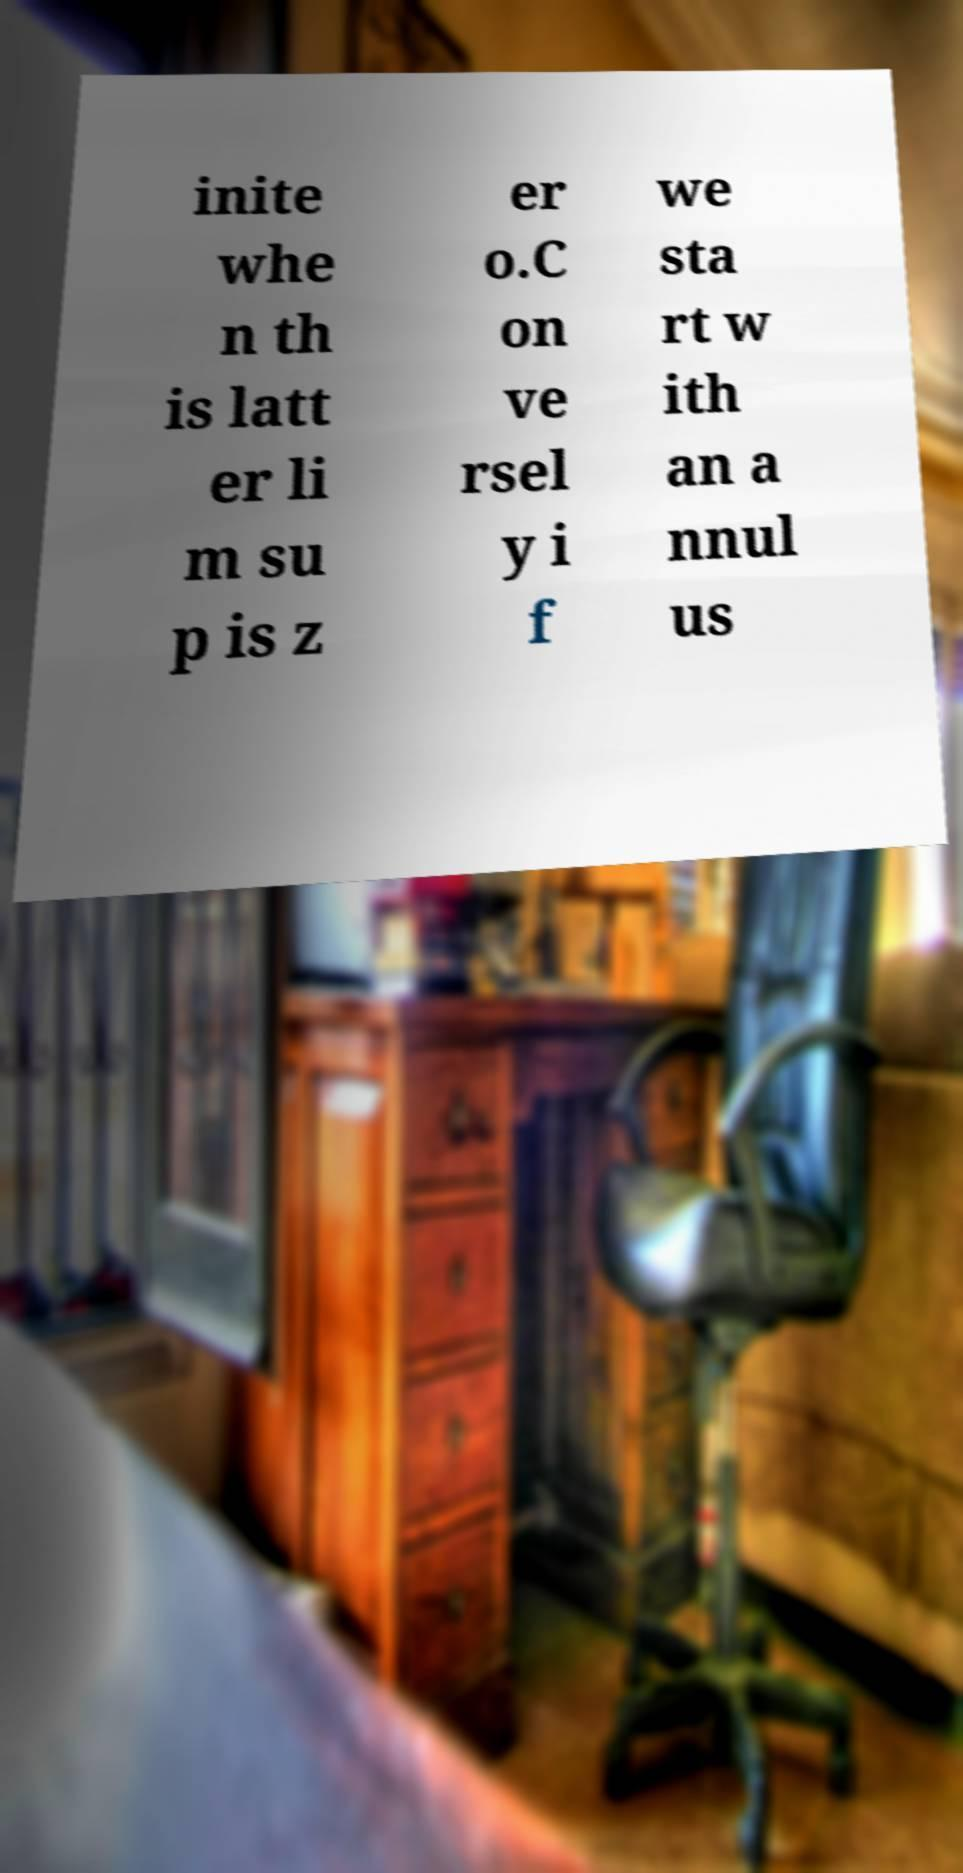Can you read and provide the text displayed in the image?This photo seems to have some interesting text. Can you extract and type it out for me? inite whe n th is latt er li m su p is z er o.C on ve rsel y i f we sta rt w ith an a nnul us 